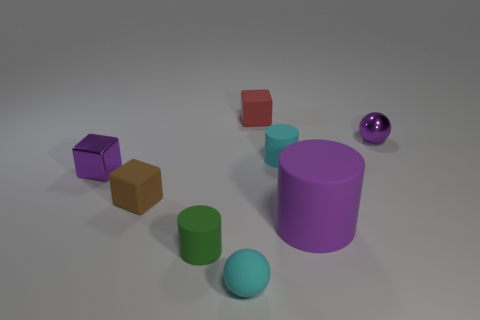Is the color of the shiny sphere the same as the tiny metallic block?
Keep it short and to the point. Yes. Are there any other things that have the same size as the purple rubber cylinder?
Your response must be concise. No. How many shiny things are either tiny things or small red blocks?
Your answer should be compact. 2. There is a cylinder that is the same color as the tiny rubber sphere; what material is it?
Ensure brevity in your answer.  Rubber. Are there fewer tiny metallic cubes that are in front of the green matte cylinder than rubber cylinders to the left of the big matte thing?
Provide a succinct answer. Yes. How many things are small purple metallic blocks or tiny objects that are to the right of the large matte thing?
Ensure brevity in your answer.  2. There is a purple sphere that is the same size as the green cylinder; what is it made of?
Provide a short and direct response. Metal. Do the small cyan ball and the small purple block have the same material?
Offer a terse response. No. There is a small block that is to the left of the tiny red thing and on the right side of the tiny purple cube; what color is it?
Your answer should be compact. Brown. There is a tiny cylinder that is behind the brown matte object; is its color the same as the matte sphere?
Make the answer very short. Yes. 